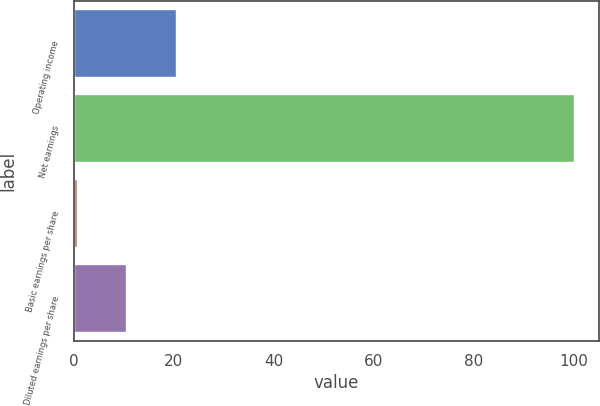<chart> <loc_0><loc_0><loc_500><loc_500><bar_chart><fcel>Operating income<fcel>Net earnings<fcel>Basic earnings per share<fcel>Diluted earnings per share<nl><fcel>20.45<fcel>100<fcel>0.57<fcel>10.51<nl></chart> 